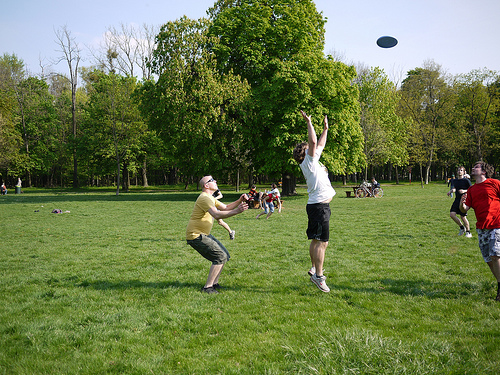What is the man to the right of the bench wearing? The man to the right of the bench is wearing a shirt and shorts, suitable for casual outdoor activities. 